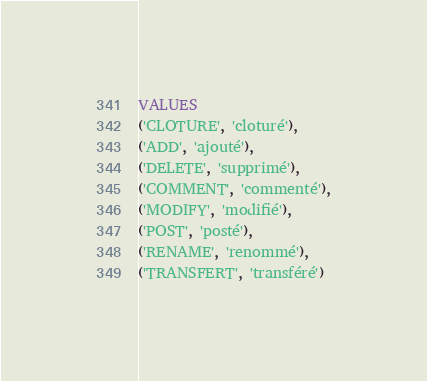Convert code to text. <code><loc_0><loc_0><loc_500><loc_500><_SQL_>VALUES 
('CLOTURE', 'cloturé'),
('ADD', 'ajouté'),
('DELETE', 'supprimé'),
('COMMENT', 'commenté'),
('MODIFY', 'modifié'),
('POST', 'posté'),
('RENAME', 'renommé'),
('TRANSFERT', 'transféré')</code> 